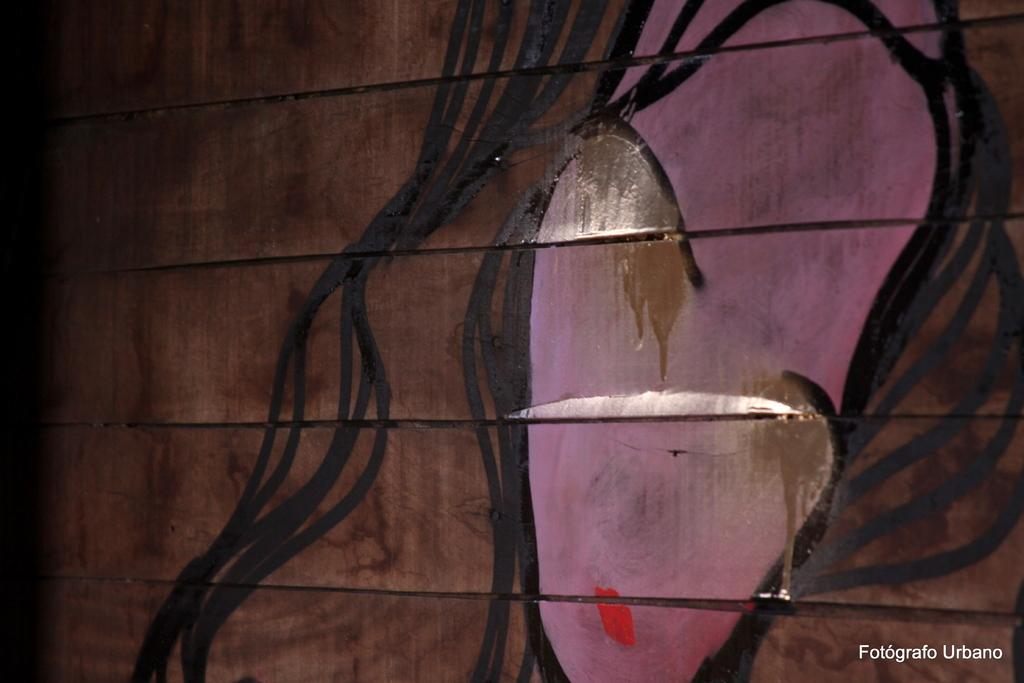What is present on the wall in the image? There is a painting on the wall in the image. What does the painting depict? The painting depicts a woman's face. What time of day does the painting depict the woman in the image? The time of day is not depicted in the painting; it only shows a woman's face. 